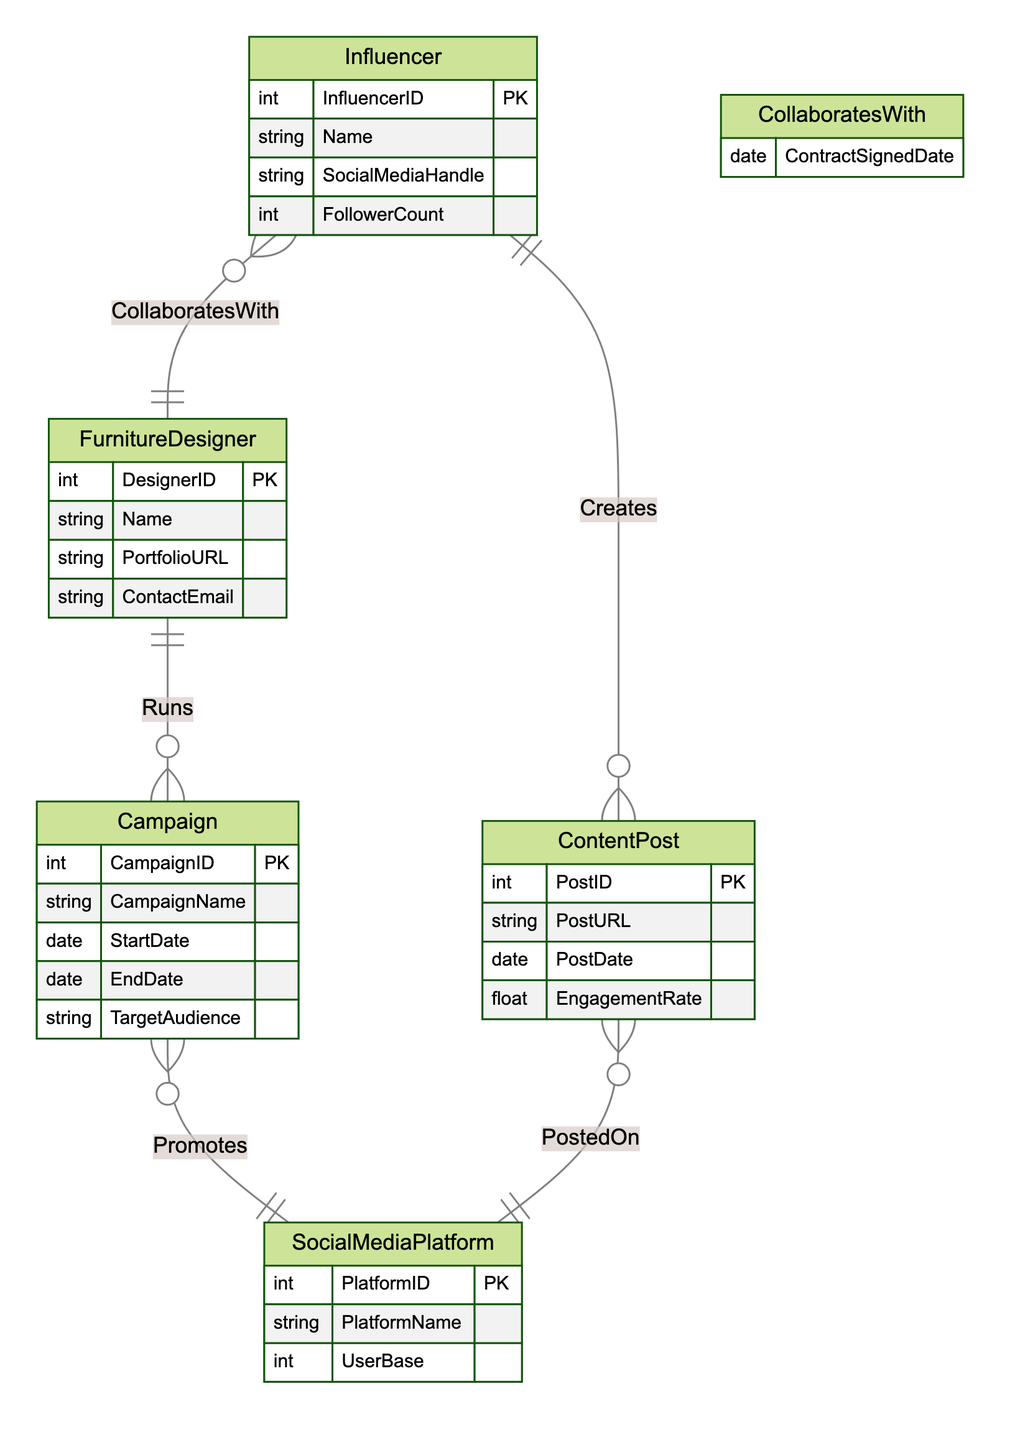What is the primary key of the FurnitureDesigner entity? The primary key for the FurnitureDesigner entity is DesignerID, which uniquely identifies each designer in the database.
Answer: DesignerID How many entities are represented in the diagram? The diagram includes five entities: FurnitureDesigner, SocialMediaPlatform, Campaign, Influencer, and ContentPost, which count totals to five.
Answer: Five What is the name of the relationship that involves Campaign and SocialMediaPlatform? The relationship connecting Campaign and SocialMediaPlatform is called Promotes, indicating that campaigns are promoted on these platforms.
Answer: Promotes What attribute is added to the CollaboratesWith relationship? The CollaboratesWith relationship includes the attribute ContractSignedDate, which indicates the date a contract was signed between an influencer and a furniture designer.
Answer: ContractSignedDate Which entity is connected to ContentPost via the Creates relationship? The Influencer entity is connected to ContentPost through the Creates relationship, meaning that influencers create content posts.
Answer: Influencer What is the engagement measure associated with ContentPost? Each ContentPost has an attribute called EngagementRate, which quantifies the level of engagement the post receives.
Answer: EngagementRate How many relationships are depicted in this diagram? There are five relationships depicted in the diagram: Runs, Promotes, CollaboratesWith, Creates, and PostedOn, making a total of five relationships.
Answer: Five Which entity has the attribute FollowerCount? The Influencer entity has the FollowerCount attribute, indicating the number of followers an influencer has on social media.
Answer: Influencer What is the key attribute that links FurnitureDesigner and Campaign? The key attribute that links FurnitureDesigner and Campaign is the Runs relationship, which signifies that a designer runs a specific campaign.
Answer: Runs How is the entity SocialMediaPlatform connected to ContentPost? The SocialMediaPlatform entity is connected to ContentPost through the PostedOn relationship, indicating that content posts are published on social media platforms.
Answer: PostedOn 